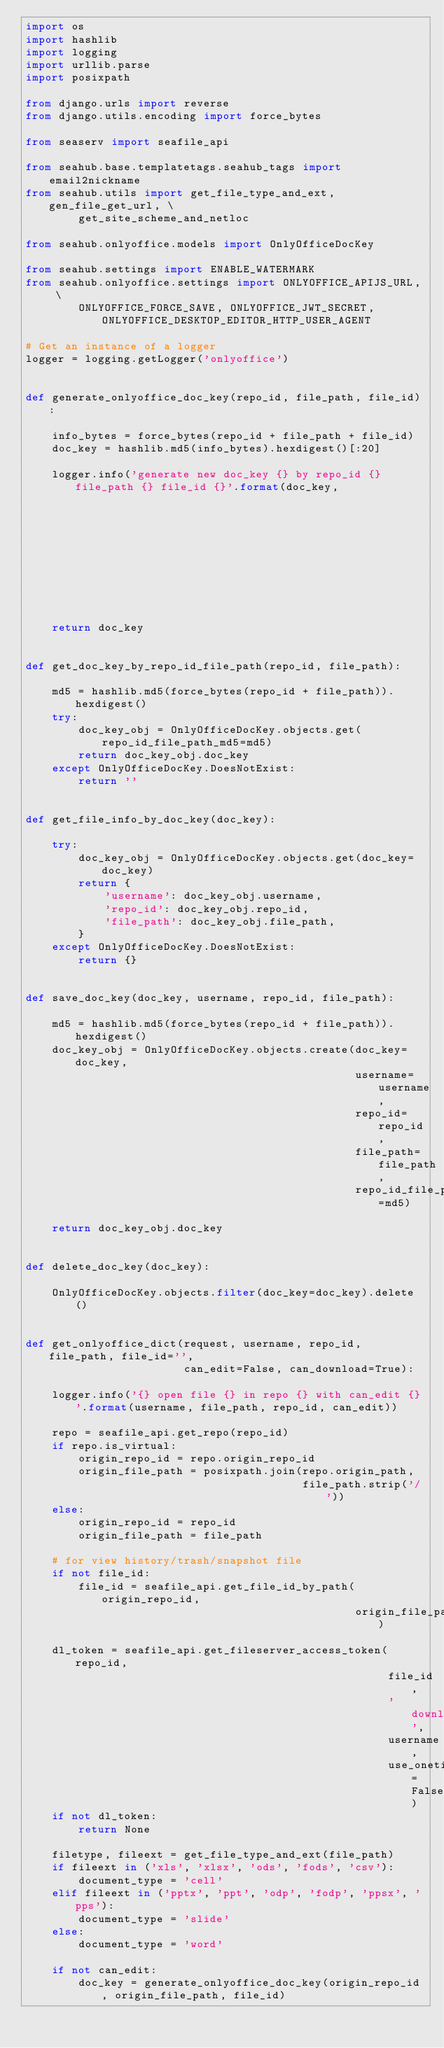<code> <loc_0><loc_0><loc_500><loc_500><_Python_>import os
import hashlib
import logging
import urllib.parse
import posixpath

from django.urls import reverse
from django.utils.encoding import force_bytes

from seaserv import seafile_api

from seahub.base.templatetags.seahub_tags import email2nickname
from seahub.utils import get_file_type_and_ext, gen_file_get_url, \
        get_site_scheme_and_netloc

from seahub.onlyoffice.models import OnlyOfficeDocKey

from seahub.settings import ENABLE_WATERMARK
from seahub.onlyoffice.settings import ONLYOFFICE_APIJS_URL, \
        ONLYOFFICE_FORCE_SAVE, ONLYOFFICE_JWT_SECRET, ONLYOFFICE_DESKTOP_EDITOR_HTTP_USER_AGENT

# Get an instance of a logger
logger = logging.getLogger('onlyoffice')


def generate_onlyoffice_doc_key(repo_id, file_path, file_id):

    info_bytes = force_bytes(repo_id + file_path + file_id)
    doc_key = hashlib.md5(info_bytes).hexdigest()[:20]

    logger.info('generate new doc_key {} by repo_id {} file_path {} file_id {}'.format(doc_key,
                                                                                       repo_id,
                                                                                       file_path,
                                                                                       file_id))
    return doc_key


def get_doc_key_by_repo_id_file_path(repo_id, file_path):

    md5 = hashlib.md5(force_bytes(repo_id + file_path)).hexdigest()
    try:
        doc_key_obj = OnlyOfficeDocKey.objects.get(repo_id_file_path_md5=md5)
        return doc_key_obj.doc_key
    except OnlyOfficeDocKey.DoesNotExist:
        return ''


def get_file_info_by_doc_key(doc_key):

    try:
        doc_key_obj = OnlyOfficeDocKey.objects.get(doc_key=doc_key)
        return {
            'username': doc_key_obj.username,
            'repo_id': doc_key_obj.repo_id,
            'file_path': doc_key_obj.file_path,
        }
    except OnlyOfficeDocKey.DoesNotExist:
        return {}


def save_doc_key(doc_key, username, repo_id, file_path):

    md5 = hashlib.md5(force_bytes(repo_id + file_path)).hexdigest()
    doc_key_obj = OnlyOfficeDocKey.objects.create(doc_key=doc_key,
                                                  username=username,
                                                  repo_id=repo_id,
                                                  file_path=file_path,
                                                  repo_id_file_path_md5=md5)

    return doc_key_obj.doc_key


def delete_doc_key(doc_key):

    OnlyOfficeDocKey.objects.filter(doc_key=doc_key).delete()


def get_onlyoffice_dict(request, username, repo_id, file_path, file_id='',
                        can_edit=False, can_download=True):

    logger.info('{} open file {} in repo {} with can_edit {}'.format(username, file_path, repo_id, can_edit))

    repo = seafile_api.get_repo(repo_id)
    if repo.is_virtual:
        origin_repo_id = repo.origin_repo_id
        origin_file_path = posixpath.join(repo.origin_path,
                                          file_path.strip('/'))
    else:
        origin_repo_id = repo_id
        origin_file_path = file_path

    # for view history/trash/snapshot file
    if not file_id:
        file_id = seafile_api.get_file_id_by_path(origin_repo_id,
                                                  origin_file_path)

    dl_token = seafile_api.get_fileserver_access_token(repo_id,
                                                       file_id,
                                                       'download',
                                                       username,
                                                       use_onetime=False)
    if not dl_token:
        return None

    filetype, fileext = get_file_type_and_ext(file_path)
    if fileext in ('xls', 'xlsx', 'ods', 'fods', 'csv'):
        document_type = 'cell'
    elif fileext in ('pptx', 'ppt', 'odp', 'fodp', 'ppsx', 'pps'):
        document_type = 'slide'
    else:
        document_type = 'word'

    if not can_edit:
        doc_key = generate_onlyoffice_doc_key(origin_repo_id, origin_file_path, file_id)</code> 